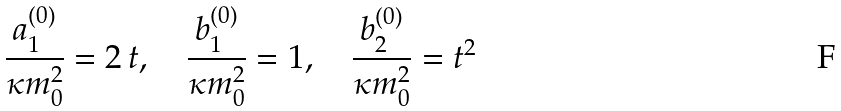<formula> <loc_0><loc_0><loc_500><loc_500>\frac { a _ { 1 } ^ { ( 0 ) } } { \kappa m _ { 0 } ^ { 2 } } = 2 \, t , \quad \frac { b _ { 1 } ^ { ( 0 ) } } { \kappa m _ { 0 } ^ { 2 } } = 1 , \quad \frac { b _ { 2 } ^ { ( 0 ) } } { \kappa m _ { 0 } ^ { 2 } } = t ^ { 2 }</formula> 